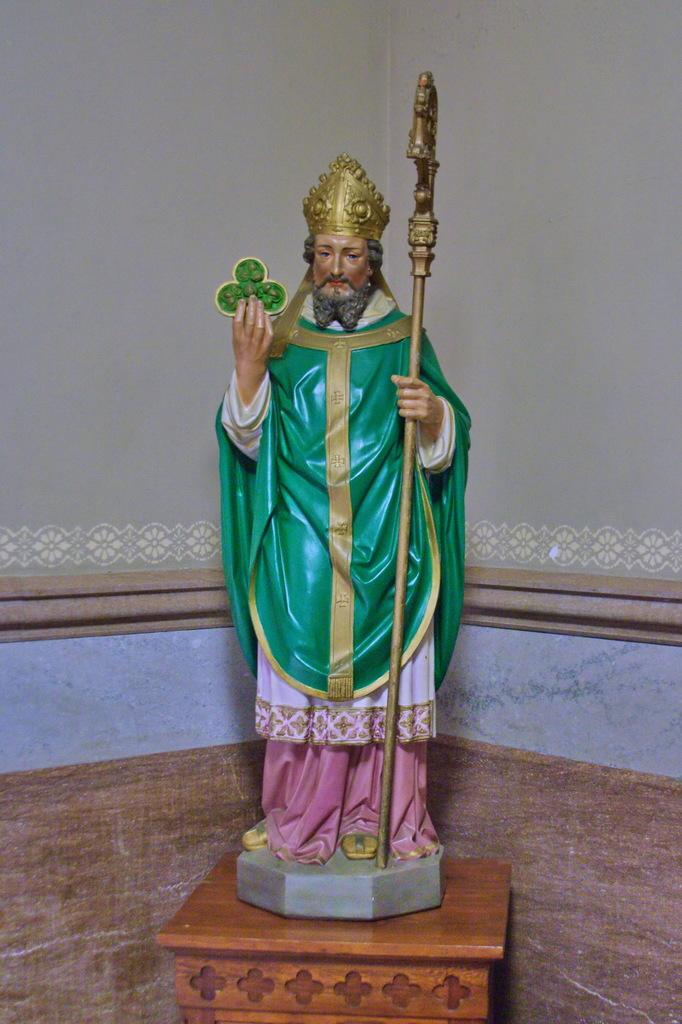What is the main subject of the image? The main subject of the image is a statue. What is the person in the statue holding? The person in the statue is holding objects in their hands. What is the statue standing on? The statue is on a wooden object. What can be seen in the background of the image? There are walls visible in the background of the image. How many pigs are sitting next to the statue in the image? There are no pigs present in the image. What type of celery is being used as a decoration on the statue? There is no celery present in the image, and the statue is not decorated with any vegetables. 